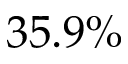Convert formula to latex. <formula><loc_0><loc_0><loc_500><loc_500>3 5 . 9 \%</formula> 